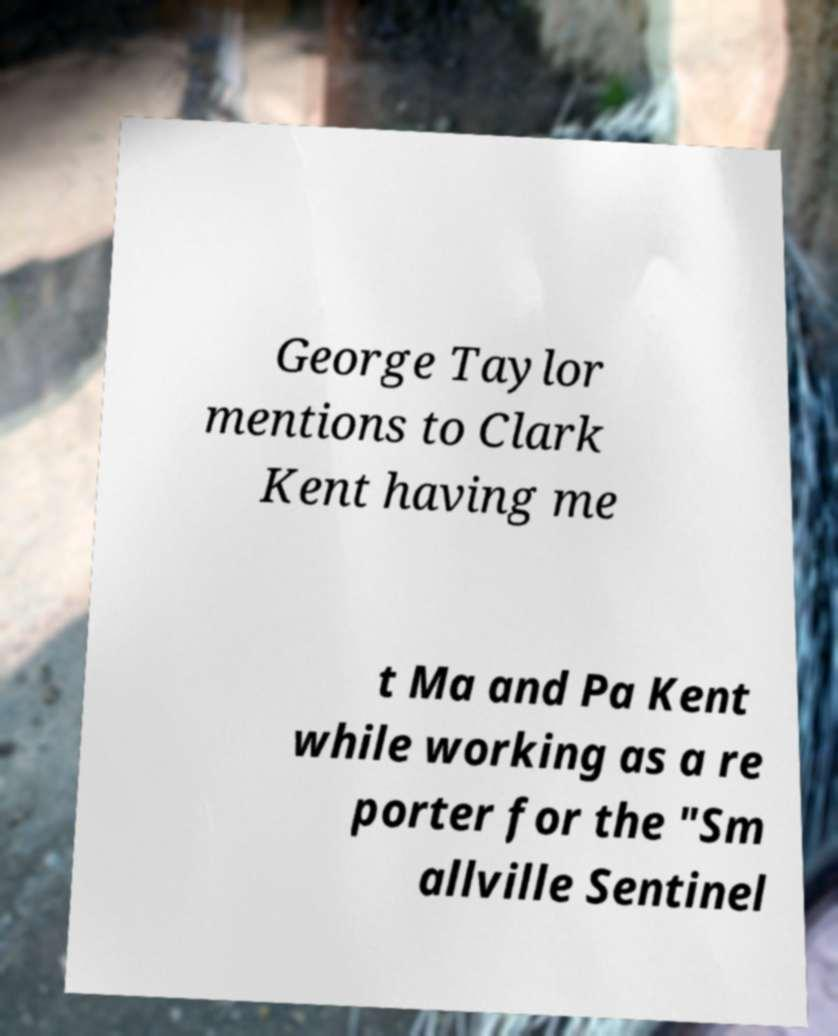Can you accurately transcribe the text from the provided image for me? George Taylor mentions to Clark Kent having me t Ma and Pa Kent while working as a re porter for the "Sm allville Sentinel 